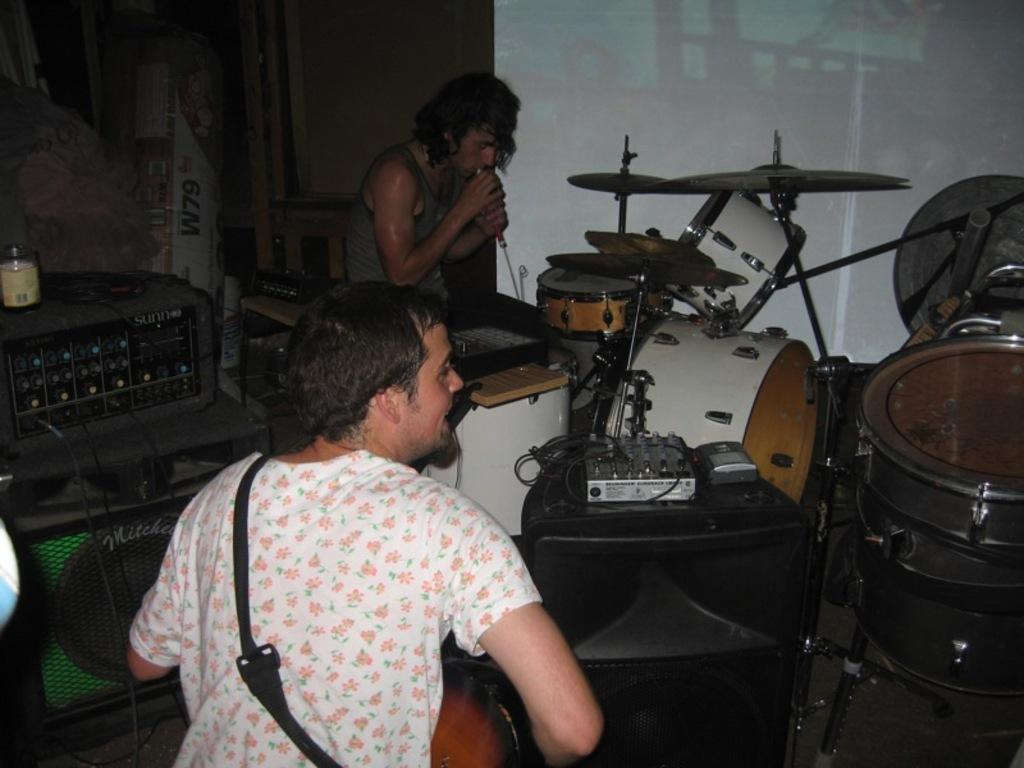How many people are in the room in the image? There are two persons in the room. What is one of the persons holding? One of the persons is holding a microphone. What else can be seen in the room besides the people? There are musical instruments and speakers in the room. What type of thread is being used to adjust the stocking on the person holding the microphone? There is no thread or stocking present in the image. 